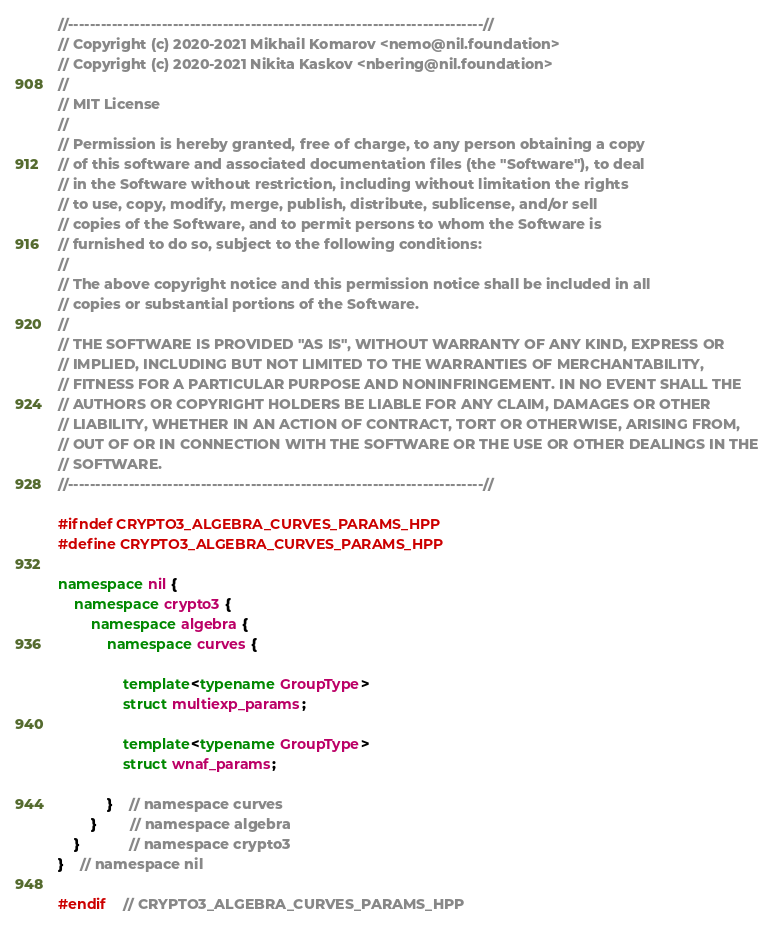Convert code to text. <code><loc_0><loc_0><loc_500><loc_500><_C++_>//---------------------------------------------------------------------------//
// Copyright (c) 2020-2021 Mikhail Komarov <nemo@nil.foundation>
// Copyright (c) 2020-2021 Nikita Kaskov <nbering@nil.foundation>
//
// MIT License
//
// Permission is hereby granted, free of charge, to any person obtaining a copy
// of this software and associated documentation files (the "Software"), to deal
// in the Software without restriction, including without limitation the rights
// to use, copy, modify, merge, publish, distribute, sublicense, and/or sell
// copies of the Software, and to permit persons to whom the Software is
// furnished to do so, subject to the following conditions:
//
// The above copyright notice and this permission notice shall be included in all
// copies or substantial portions of the Software.
//
// THE SOFTWARE IS PROVIDED "AS IS", WITHOUT WARRANTY OF ANY KIND, EXPRESS OR
// IMPLIED, INCLUDING BUT NOT LIMITED TO THE WARRANTIES OF MERCHANTABILITY,
// FITNESS FOR A PARTICULAR PURPOSE AND NONINFRINGEMENT. IN NO EVENT SHALL THE
// AUTHORS OR COPYRIGHT HOLDERS BE LIABLE FOR ANY CLAIM, DAMAGES OR OTHER
// LIABILITY, WHETHER IN AN ACTION OF CONTRACT, TORT OR OTHERWISE, ARISING FROM,
// OUT OF OR IN CONNECTION WITH THE SOFTWARE OR THE USE OR OTHER DEALINGS IN THE
// SOFTWARE.
//---------------------------------------------------------------------------//

#ifndef CRYPTO3_ALGEBRA_CURVES_PARAMS_HPP
#define CRYPTO3_ALGEBRA_CURVES_PARAMS_HPP

namespace nil {
    namespace crypto3 {
        namespace algebra {
            namespace curves {

                template<typename GroupType>
                struct multiexp_params;

                template<typename GroupType>
                struct wnaf_params;

            }    // namespace curves
        }        // namespace algebra
    }            // namespace crypto3
}    // namespace nil

#endif    // CRYPTO3_ALGEBRA_CURVES_PARAMS_HPP
</code> 